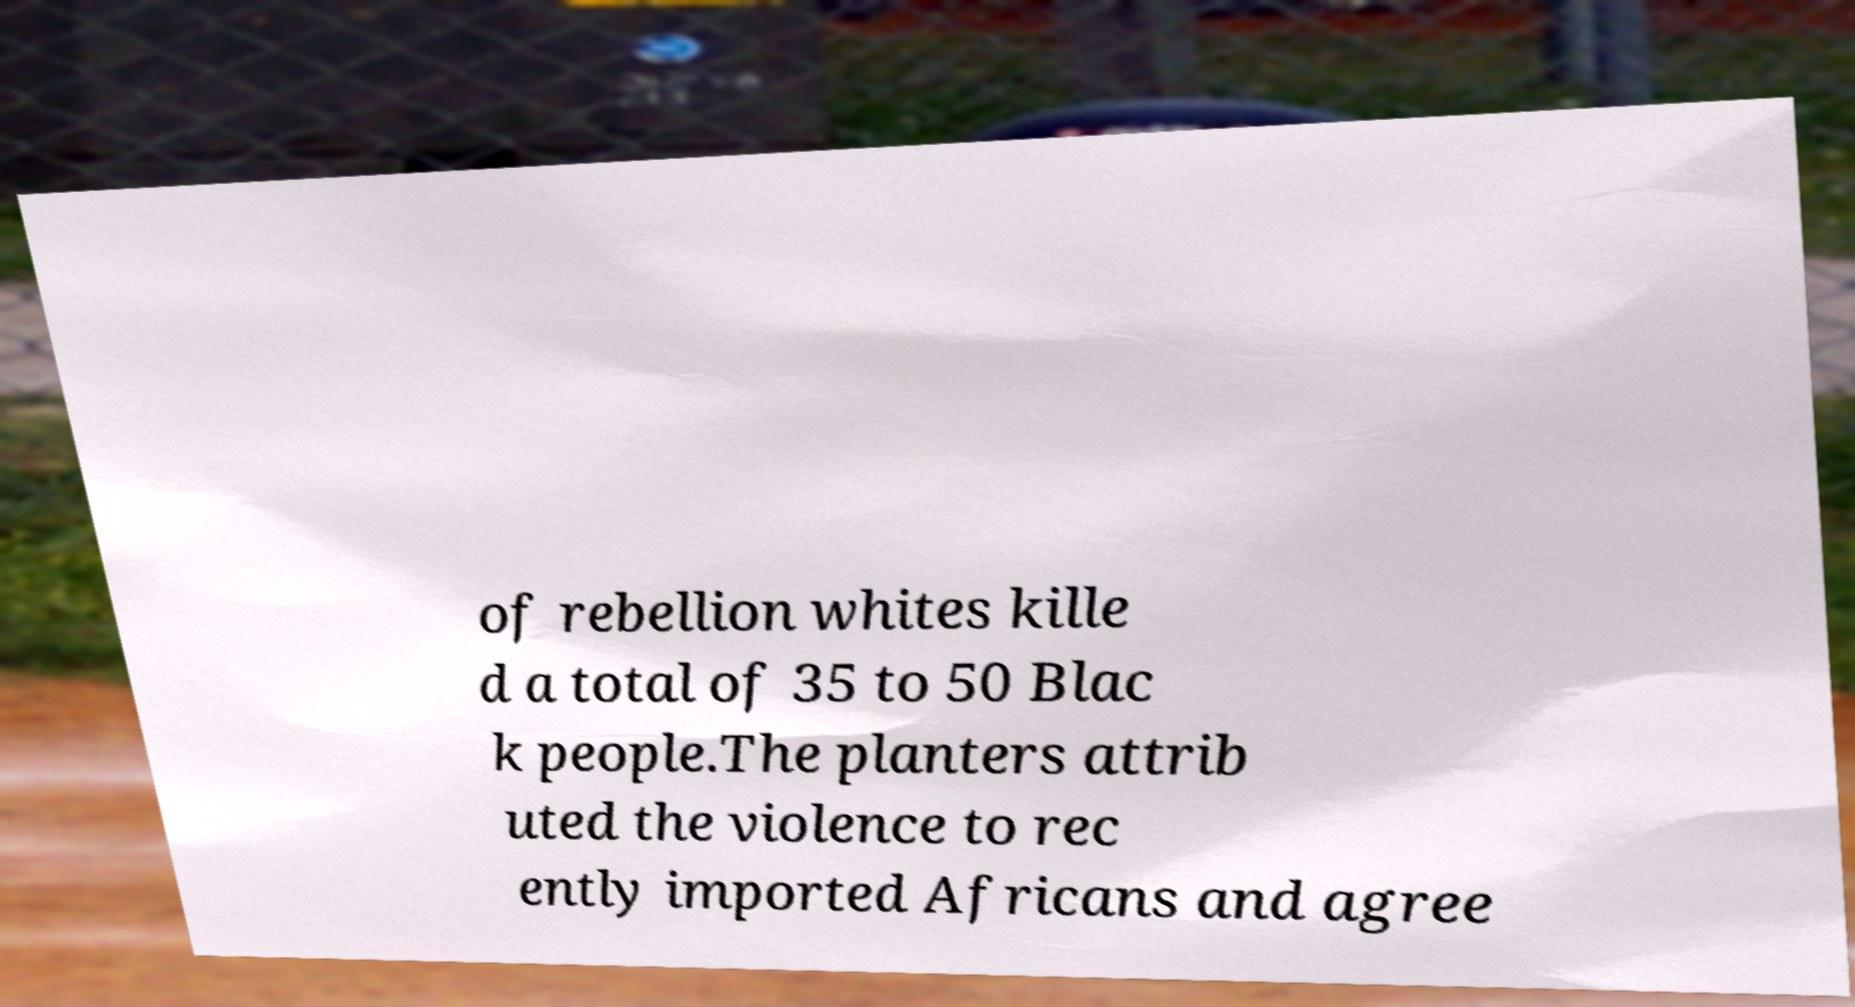What messages or text are displayed in this image? I need them in a readable, typed format. of rebellion whites kille d a total of 35 to 50 Blac k people.The planters attrib uted the violence to rec ently imported Africans and agree 